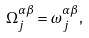<formula> <loc_0><loc_0><loc_500><loc_500>\Omega _ { j } ^ { \alpha \beta } = \omega _ { j } ^ { \alpha \beta } ,</formula> 